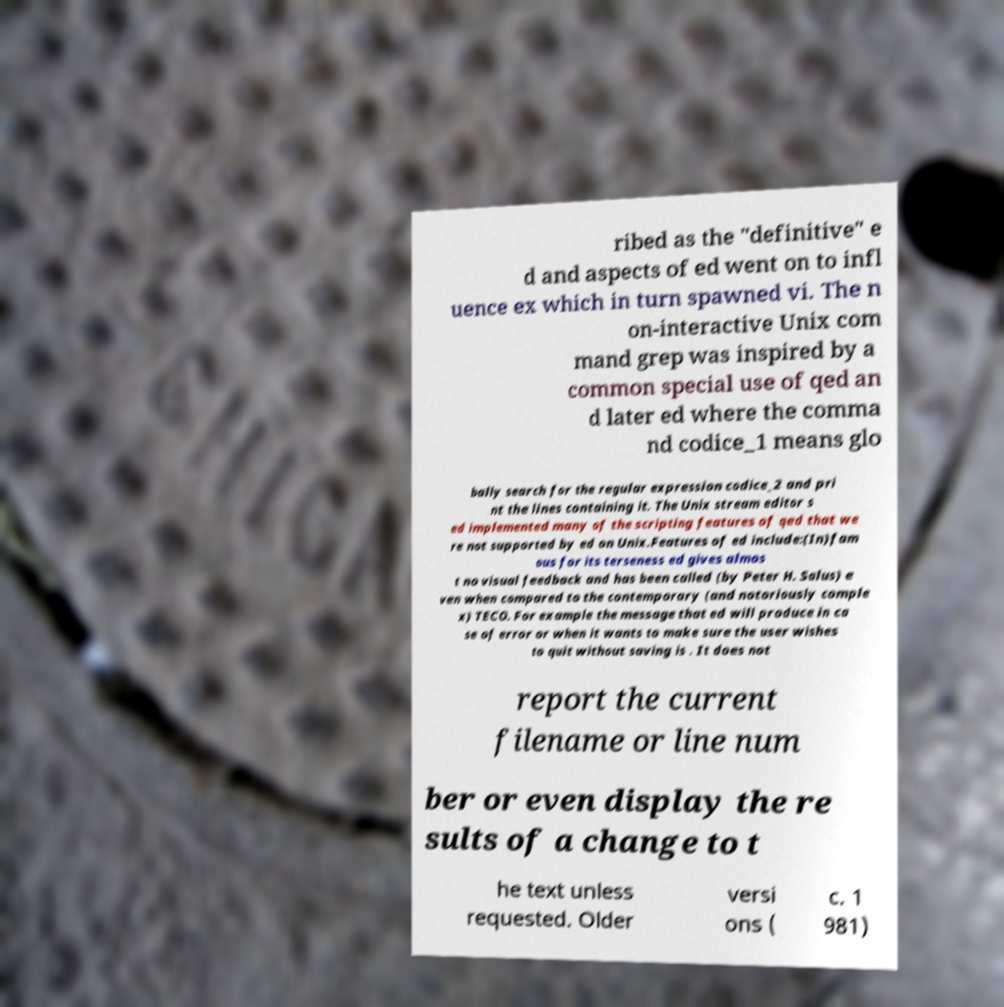I need the written content from this picture converted into text. Can you do that? ribed as the "definitive" e d and aspects of ed went on to infl uence ex which in turn spawned vi. The n on-interactive Unix com mand grep was inspired by a common special use of qed an d later ed where the comma nd codice_1 means glo bally search for the regular expression codice_2 and pri nt the lines containing it. The Unix stream editor s ed implemented many of the scripting features of qed that we re not supported by ed on Unix.Features of ed include:(In)fam ous for its terseness ed gives almos t no visual feedback and has been called (by Peter H. Salus) e ven when compared to the contemporary (and notoriously comple x) TECO. For example the message that ed will produce in ca se of error or when it wants to make sure the user wishes to quit without saving is . It does not report the current filename or line num ber or even display the re sults of a change to t he text unless requested. Older versi ons ( c. 1 981) 